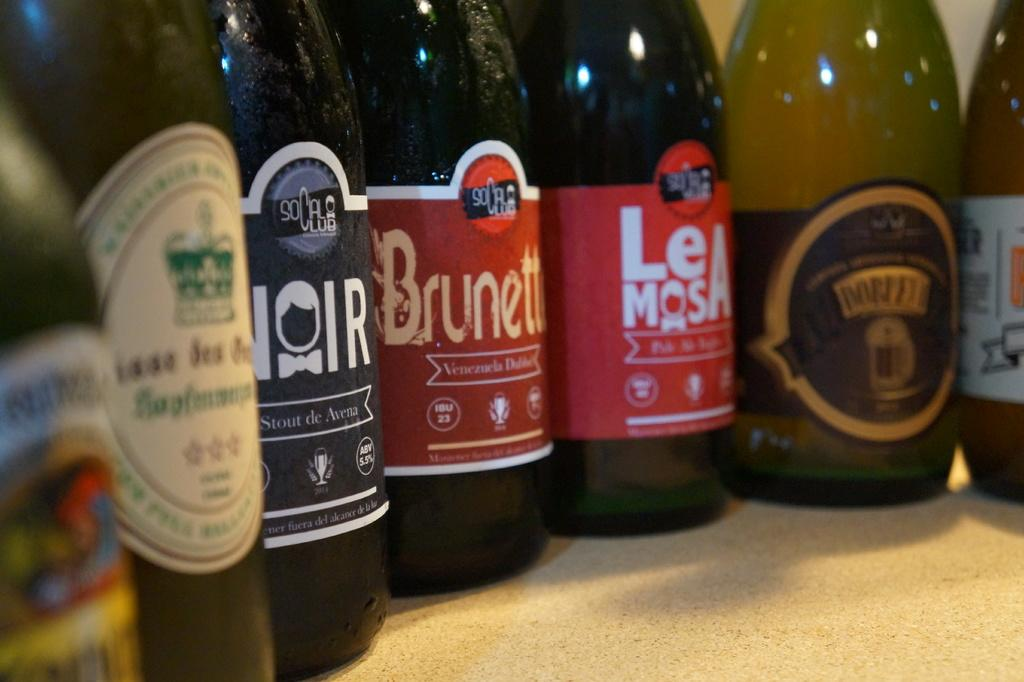<image>
Render a clear and concise summary of the photo. Bottles of beer with different names and labels, at least two are from socalclub., 